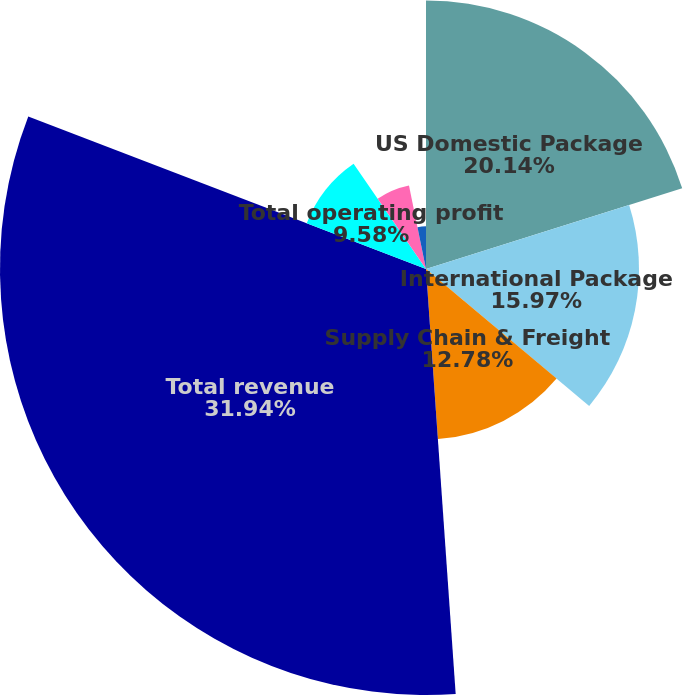<chart> <loc_0><loc_0><loc_500><loc_500><pie_chart><fcel>US Domestic Package<fcel>International Package<fcel>Supply Chain & Freight<fcel>Total revenue<fcel>Total operating profit<fcel>Net Income<fcel>Basic<fcel>Diluted<nl><fcel>20.14%<fcel>15.97%<fcel>12.78%<fcel>31.94%<fcel>9.58%<fcel>6.39%<fcel>3.2%<fcel>0.0%<nl></chart> 